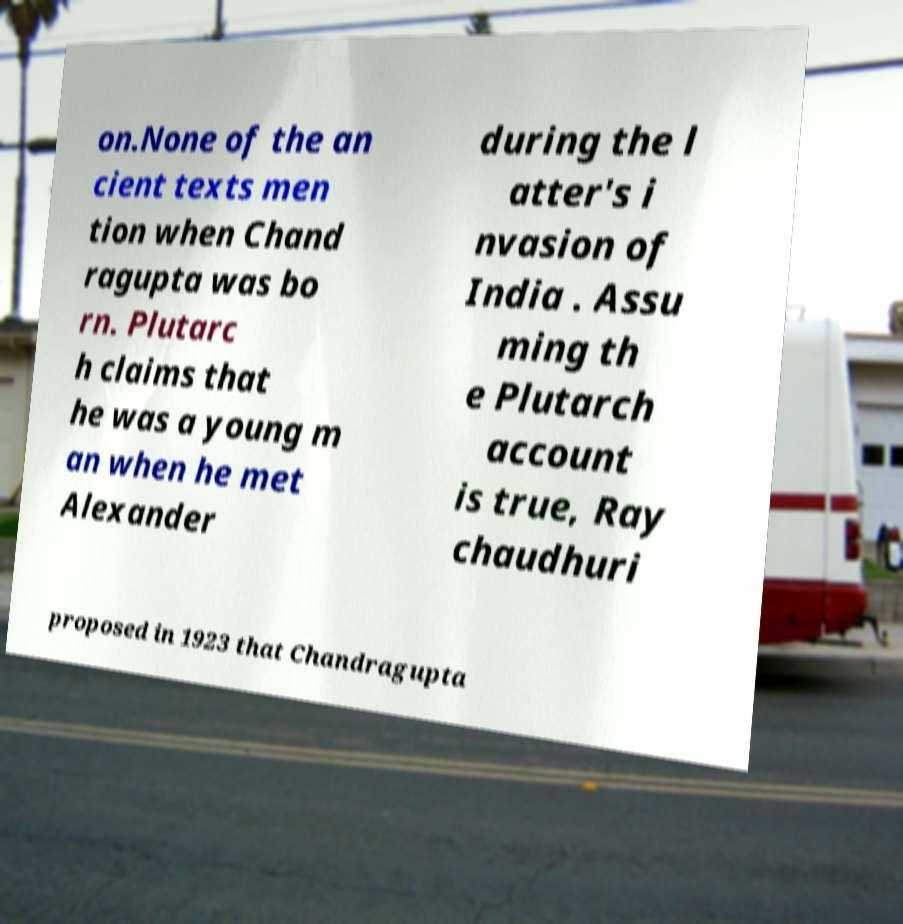Please identify and transcribe the text found in this image. on.None of the an cient texts men tion when Chand ragupta was bo rn. Plutarc h claims that he was a young m an when he met Alexander during the l atter's i nvasion of India . Assu ming th e Plutarch account is true, Ray chaudhuri proposed in 1923 that Chandragupta 